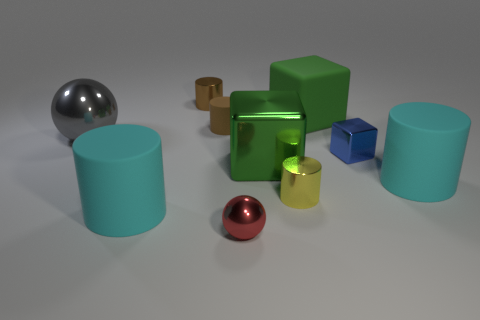Subtract all small yellow cylinders. How many cylinders are left? 4 Subtract all gray spheres. How many spheres are left? 1 Subtract all cubes. How many objects are left? 7 Subtract 3 blocks. How many blocks are left? 0 Add 5 shiny balls. How many shiny balls are left? 7 Add 7 large cylinders. How many large cylinders exist? 9 Subtract 0 brown blocks. How many objects are left? 10 Subtract all red balls. Subtract all green cubes. How many balls are left? 1 Subtract all cyan blocks. How many brown cylinders are left? 2 Subtract all small cyan rubber objects. Subtract all big green rubber things. How many objects are left? 9 